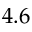<formula> <loc_0><loc_0><loc_500><loc_500>4 . 6</formula> 